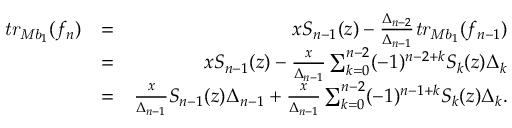<formula> <loc_0><loc_0><loc_500><loc_500>\begin{array} { r l r } { t r _ { M b _ { 1 } } ( f _ { n } ) } & { = } & { x S _ { n - 1 } ( z ) - \frac { \Delta _ { n - 2 } } { \Delta _ { n - 1 } } t r _ { M b _ { 1 } } ( f _ { n - 1 } ) } \\ & { = } & { x S _ { n - 1 } ( z ) - \frac { x } { \Delta _ { n - 1 } } \sum _ { k = 0 } ^ { n - 2 } ( - 1 ) ^ { n - 2 + k } S _ { k } ( z ) \Delta _ { k } } \\ & { = } & { \frac { x } { \Delta _ { n - 1 } } S _ { n - 1 } ( z ) \Delta _ { n - 1 } + \frac { x } { \Delta _ { n - 1 } } \sum _ { k = 0 } ^ { n - 2 } ( - 1 ) ^ { n - 1 + k } S _ { k } ( z ) \Delta _ { k } . } \end{array}</formula> 